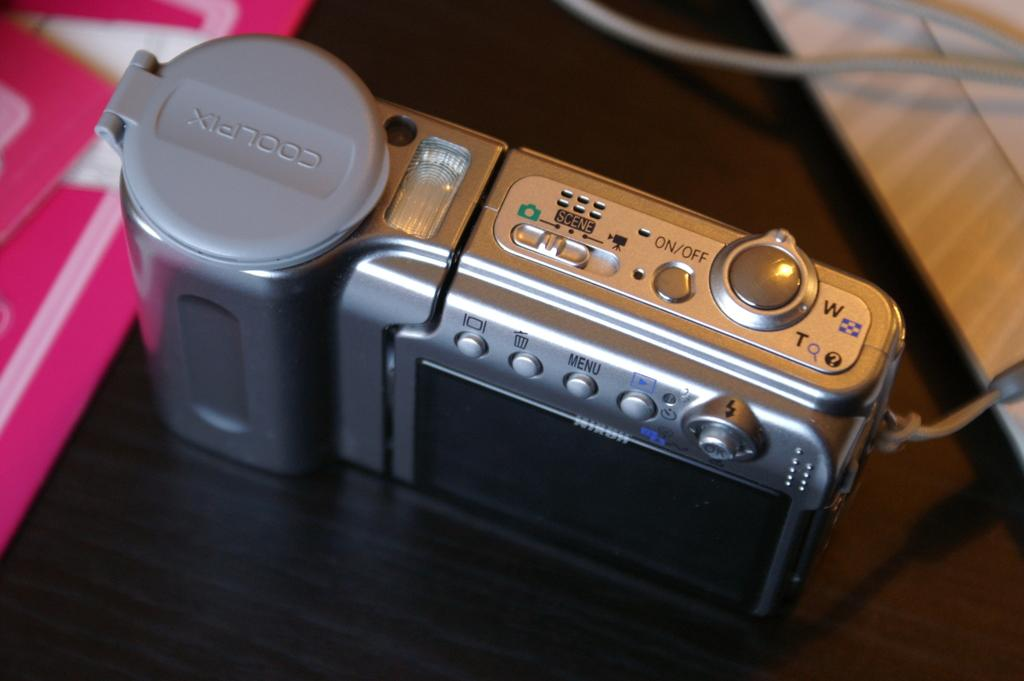What is the main object on the table in the image? There is a silver camera on a table in the image. What color is the object on the left side of the image? The object on the left side of the image has a pink color. What type of juice is being poured from the cap in the image? There is no juice or cap present in the image. 